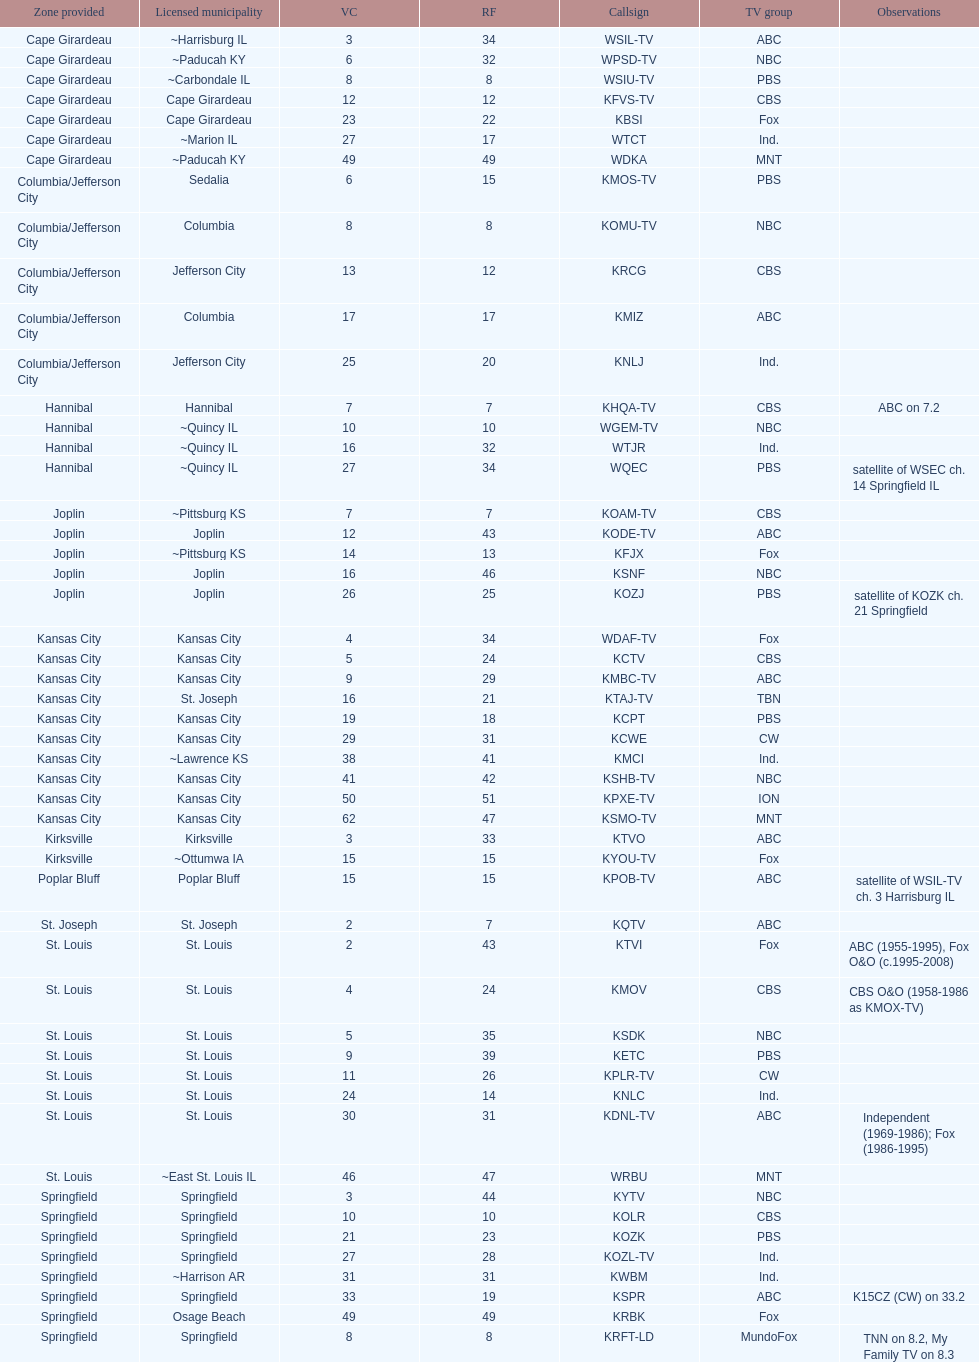Help me parse the entirety of this table. {'header': ['Zone provided', 'Licensed municipality', 'VC', 'RF', 'Callsign', 'TV group', 'Observations'], 'rows': [['Cape Girardeau', '~Harrisburg IL', '3', '34', 'WSIL-TV', 'ABC', ''], ['Cape Girardeau', '~Paducah KY', '6', '32', 'WPSD-TV', 'NBC', ''], ['Cape Girardeau', '~Carbondale IL', '8', '8', 'WSIU-TV', 'PBS', ''], ['Cape Girardeau', 'Cape Girardeau', '12', '12', 'KFVS-TV', 'CBS', ''], ['Cape Girardeau', 'Cape Girardeau', '23', '22', 'KBSI', 'Fox', ''], ['Cape Girardeau', '~Marion IL', '27', '17', 'WTCT', 'Ind.', ''], ['Cape Girardeau', '~Paducah KY', '49', '49', 'WDKA', 'MNT', ''], ['Columbia/Jefferson City', 'Sedalia', '6', '15', 'KMOS-TV', 'PBS', ''], ['Columbia/Jefferson City', 'Columbia', '8', '8', 'KOMU-TV', 'NBC', ''], ['Columbia/Jefferson City', 'Jefferson City', '13', '12', 'KRCG', 'CBS', ''], ['Columbia/Jefferson City', 'Columbia', '17', '17', 'KMIZ', 'ABC', ''], ['Columbia/Jefferson City', 'Jefferson City', '25', '20', 'KNLJ', 'Ind.', ''], ['Hannibal', 'Hannibal', '7', '7', 'KHQA-TV', 'CBS', 'ABC on 7.2'], ['Hannibal', '~Quincy IL', '10', '10', 'WGEM-TV', 'NBC', ''], ['Hannibal', '~Quincy IL', '16', '32', 'WTJR', 'Ind.', ''], ['Hannibal', '~Quincy IL', '27', '34', 'WQEC', 'PBS', 'satellite of WSEC ch. 14 Springfield IL'], ['Joplin', '~Pittsburg KS', '7', '7', 'KOAM-TV', 'CBS', ''], ['Joplin', 'Joplin', '12', '43', 'KODE-TV', 'ABC', ''], ['Joplin', '~Pittsburg KS', '14', '13', 'KFJX', 'Fox', ''], ['Joplin', 'Joplin', '16', '46', 'KSNF', 'NBC', ''], ['Joplin', 'Joplin', '26', '25', 'KOZJ', 'PBS', 'satellite of KOZK ch. 21 Springfield'], ['Kansas City', 'Kansas City', '4', '34', 'WDAF-TV', 'Fox', ''], ['Kansas City', 'Kansas City', '5', '24', 'KCTV', 'CBS', ''], ['Kansas City', 'Kansas City', '9', '29', 'KMBC-TV', 'ABC', ''], ['Kansas City', 'St. Joseph', '16', '21', 'KTAJ-TV', 'TBN', ''], ['Kansas City', 'Kansas City', '19', '18', 'KCPT', 'PBS', ''], ['Kansas City', 'Kansas City', '29', '31', 'KCWE', 'CW', ''], ['Kansas City', '~Lawrence KS', '38', '41', 'KMCI', 'Ind.', ''], ['Kansas City', 'Kansas City', '41', '42', 'KSHB-TV', 'NBC', ''], ['Kansas City', 'Kansas City', '50', '51', 'KPXE-TV', 'ION', ''], ['Kansas City', 'Kansas City', '62', '47', 'KSMO-TV', 'MNT', ''], ['Kirksville', 'Kirksville', '3', '33', 'KTVO', 'ABC', ''], ['Kirksville', '~Ottumwa IA', '15', '15', 'KYOU-TV', 'Fox', ''], ['Poplar Bluff', 'Poplar Bluff', '15', '15', 'KPOB-TV', 'ABC', 'satellite of WSIL-TV ch. 3 Harrisburg IL'], ['St. Joseph', 'St. Joseph', '2', '7', 'KQTV', 'ABC', ''], ['St. Louis', 'St. Louis', '2', '43', 'KTVI', 'Fox', 'ABC (1955-1995), Fox O&O (c.1995-2008)'], ['St. Louis', 'St. Louis', '4', '24', 'KMOV', 'CBS', 'CBS O&O (1958-1986 as KMOX-TV)'], ['St. Louis', 'St. Louis', '5', '35', 'KSDK', 'NBC', ''], ['St. Louis', 'St. Louis', '9', '39', 'KETC', 'PBS', ''], ['St. Louis', 'St. Louis', '11', '26', 'KPLR-TV', 'CW', ''], ['St. Louis', 'St. Louis', '24', '14', 'KNLC', 'Ind.', ''], ['St. Louis', 'St. Louis', '30', '31', 'KDNL-TV', 'ABC', 'Independent (1969-1986); Fox (1986-1995)'], ['St. Louis', '~East St. Louis IL', '46', '47', 'WRBU', 'MNT', ''], ['Springfield', 'Springfield', '3', '44', 'KYTV', 'NBC', ''], ['Springfield', 'Springfield', '10', '10', 'KOLR', 'CBS', ''], ['Springfield', 'Springfield', '21', '23', 'KOZK', 'PBS', ''], ['Springfield', 'Springfield', '27', '28', 'KOZL-TV', 'Ind.', ''], ['Springfield', '~Harrison AR', '31', '31', 'KWBM', 'Ind.', ''], ['Springfield', 'Springfield', '33', '19', 'KSPR', 'ABC', 'K15CZ (CW) on 33.2'], ['Springfield', 'Osage Beach', '49', '49', 'KRBK', 'Fox', ''], ['Springfield', 'Springfield', '8', '8', 'KRFT-LD', 'MundoFox', 'TNN on 8.2, My Family TV on 8.3']]} Kode-tv and wsil-tv both are a part of which network? ABC. 